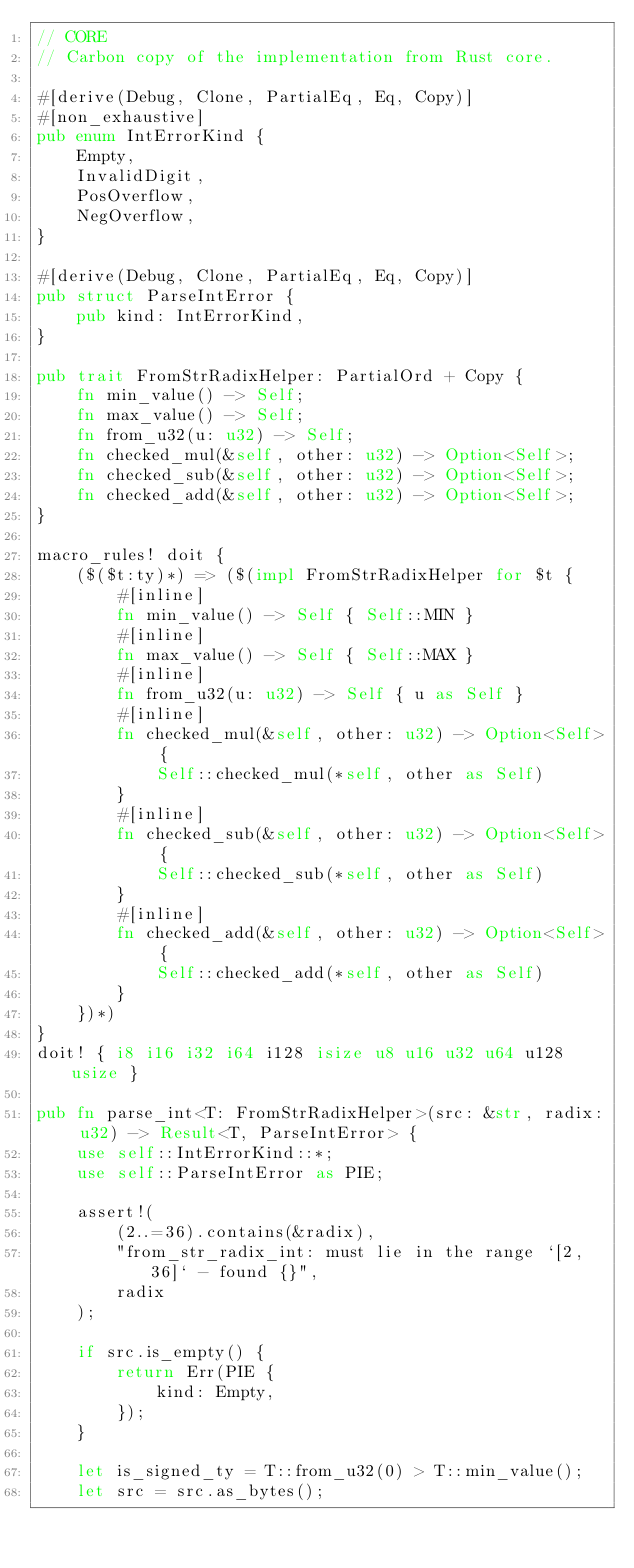<code> <loc_0><loc_0><loc_500><loc_500><_Rust_>// CORE
// Carbon copy of the implementation from Rust core.

#[derive(Debug, Clone, PartialEq, Eq, Copy)]
#[non_exhaustive]
pub enum IntErrorKind {
    Empty,
    InvalidDigit,
    PosOverflow,
    NegOverflow,
}

#[derive(Debug, Clone, PartialEq, Eq, Copy)]
pub struct ParseIntError {
    pub kind: IntErrorKind,
}

pub trait FromStrRadixHelper: PartialOrd + Copy {
    fn min_value() -> Self;
    fn max_value() -> Self;
    fn from_u32(u: u32) -> Self;
    fn checked_mul(&self, other: u32) -> Option<Self>;
    fn checked_sub(&self, other: u32) -> Option<Self>;
    fn checked_add(&self, other: u32) -> Option<Self>;
}

macro_rules! doit {
    ($($t:ty)*) => ($(impl FromStrRadixHelper for $t {
        #[inline]
        fn min_value() -> Self { Self::MIN }
        #[inline]
        fn max_value() -> Self { Self::MAX }
        #[inline]
        fn from_u32(u: u32) -> Self { u as Self }
        #[inline]
        fn checked_mul(&self, other: u32) -> Option<Self> {
            Self::checked_mul(*self, other as Self)
        }
        #[inline]
        fn checked_sub(&self, other: u32) -> Option<Self> {
            Self::checked_sub(*self, other as Self)
        }
        #[inline]
        fn checked_add(&self, other: u32) -> Option<Self> {
            Self::checked_add(*self, other as Self)
        }
    })*)
}
doit! { i8 i16 i32 i64 i128 isize u8 u16 u32 u64 u128 usize }

pub fn parse_int<T: FromStrRadixHelper>(src: &str, radix: u32) -> Result<T, ParseIntError> {
    use self::IntErrorKind::*;
    use self::ParseIntError as PIE;

    assert!(
        (2..=36).contains(&radix),
        "from_str_radix_int: must lie in the range `[2, 36]` - found {}",
        radix
    );

    if src.is_empty() {
        return Err(PIE {
            kind: Empty,
        });
    }

    let is_signed_ty = T::from_u32(0) > T::min_value();
    let src = src.as_bytes();
</code> 